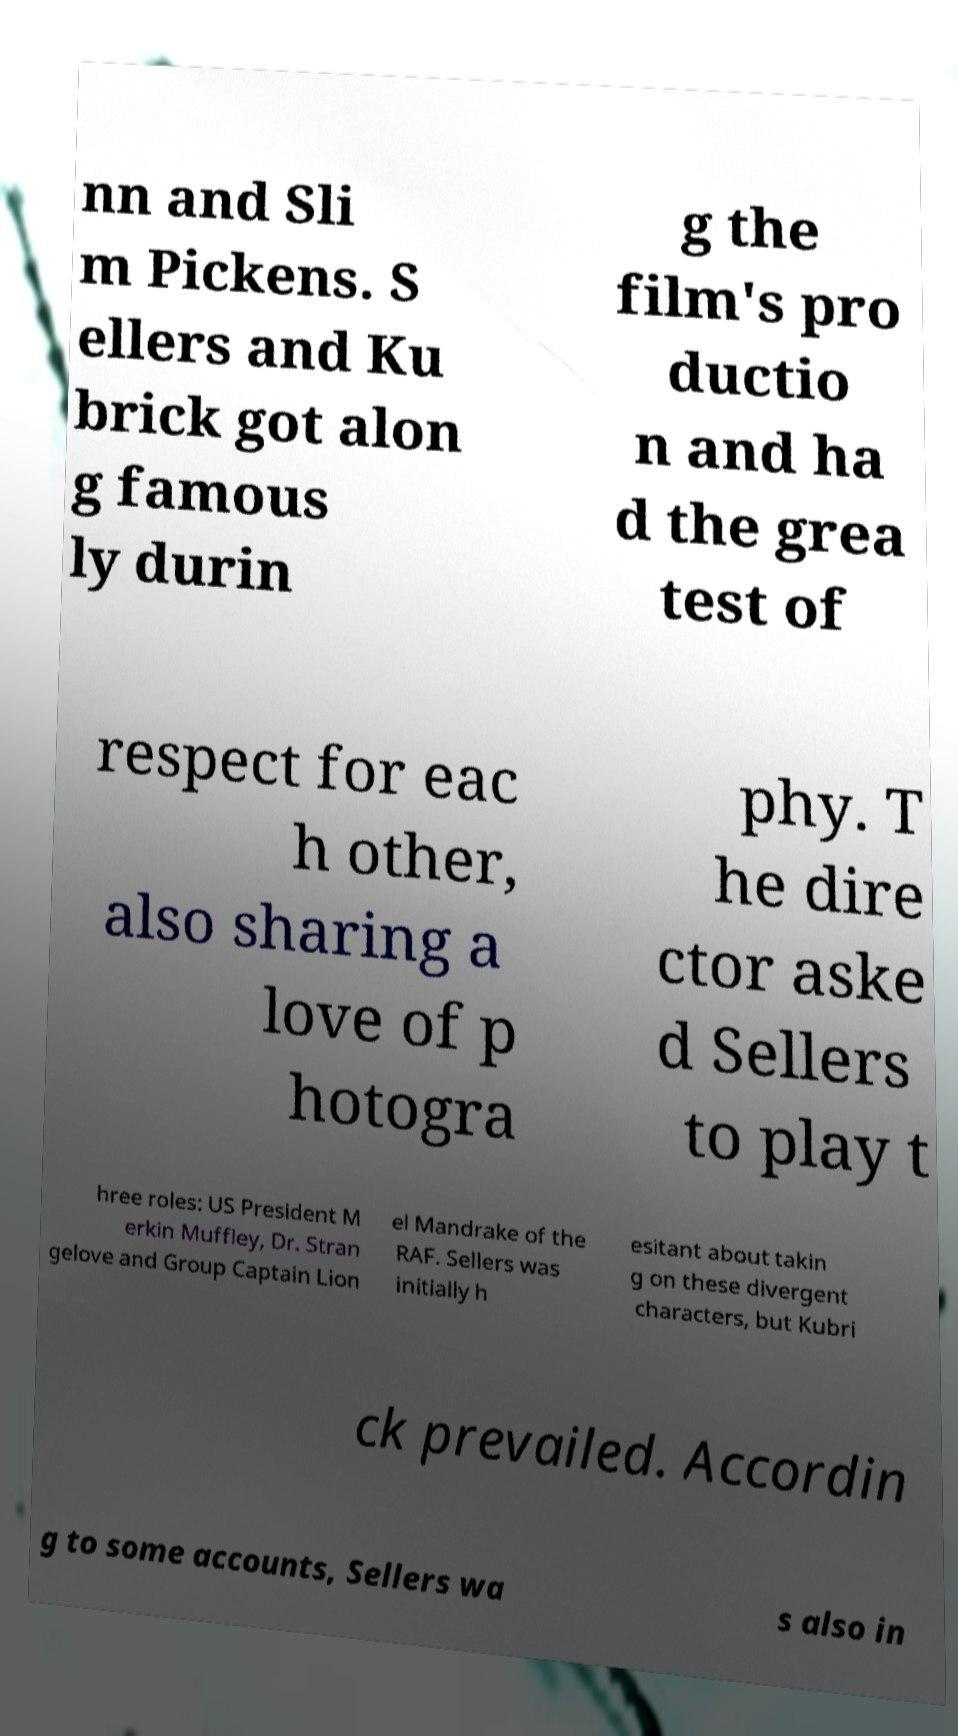What messages or text are displayed in this image? I need them in a readable, typed format. nn and Sli m Pickens. S ellers and Ku brick got alon g famous ly durin g the film's pro ductio n and ha d the grea test of respect for eac h other, also sharing a love of p hotogra phy. T he dire ctor aske d Sellers to play t hree roles: US President M erkin Muffley, Dr. Stran gelove and Group Captain Lion el Mandrake of the RAF. Sellers was initially h esitant about takin g on these divergent characters, but Kubri ck prevailed. Accordin g to some accounts, Sellers wa s also in 